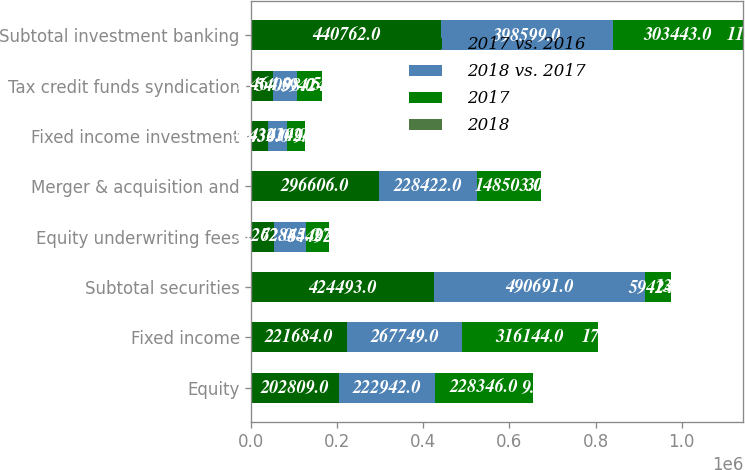<chart> <loc_0><loc_0><loc_500><loc_500><stacked_bar_chart><ecel><fcel>Equity<fcel>Fixed income<fcel>Subtotal securities<fcel>Equity underwriting fees<fcel>Merger & acquisition and<fcel>Fixed income investment<fcel>Tax credit funds syndication<fcel>Subtotal investment banking<nl><fcel>2017 vs. 2016<fcel>202809<fcel>221684<fcel>424493<fcel>53262<fcel>296606<fcel>39430<fcel>51464<fcel>440762<nl><fcel>2018 vs. 2017<fcel>222942<fcel>267749<fcel>490691<fcel>72845<fcel>228422<fcel>43234<fcel>54098<fcel>398599<nl><fcel>2017<fcel>228346<fcel>316144<fcel>59424<fcel>54492<fcel>148503<fcel>41024<fcel>59424<fcel>303443<nl><fcel>2018<fcel>9<fcel>17<fcel>13<fcel>27<fcel>30<fcel>9<fcel>5<fcel>11<nl></chart> 